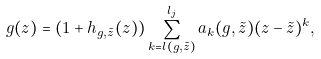Convert formula to latex. <formula><loc_0><loc_0><loc_500><loc_500>g ( z ) = \left ( 1 + h _ { g , \tilde { z } } ( z ) \right ) \sum _ { k = l ( g , \tilde { z } ) } ^ { l _ { j } } a _ { k } ( g , \tilde { z } ) ( z - \tilde { z } ) ^ { k } ,</formula> 